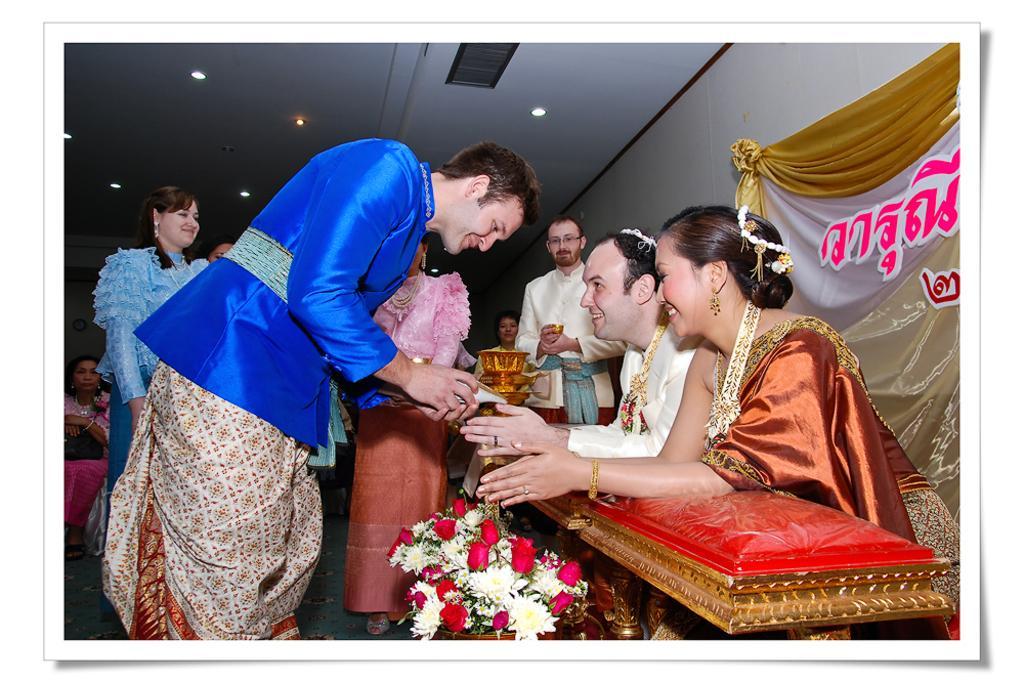In one or two sentences, can you explain what this image depicts? On the right side of the image we can see man and woman sitting on the chairs. On the right side of the image we can see flower vase and persons standing on the floor. In the background we can see curtain, wall, lights and persons. 